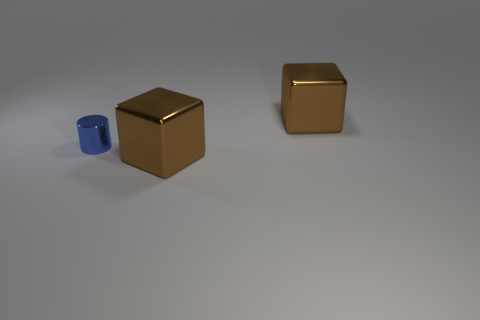Add 1 big brown metallic things. How many objects exist? 4 Add 3 brown metal objects. How many brown metal objects are left? 5 Add 3 tiny cyan cylinders. How many tiny cyan cylinders exist? 3 Subtract 0 gray cylinders. How many objects are left? 3 Subtract all cylinders. How many objects are left? 2 Subtract 1 blocks. How many blocks are left? 1 Subtract all yellow blocks. Subtract all cyan balls. How many blocks are left? 2 Subtract all big yellow metallic spheres. Subtract all brown cubes. How many objects are left? 1 